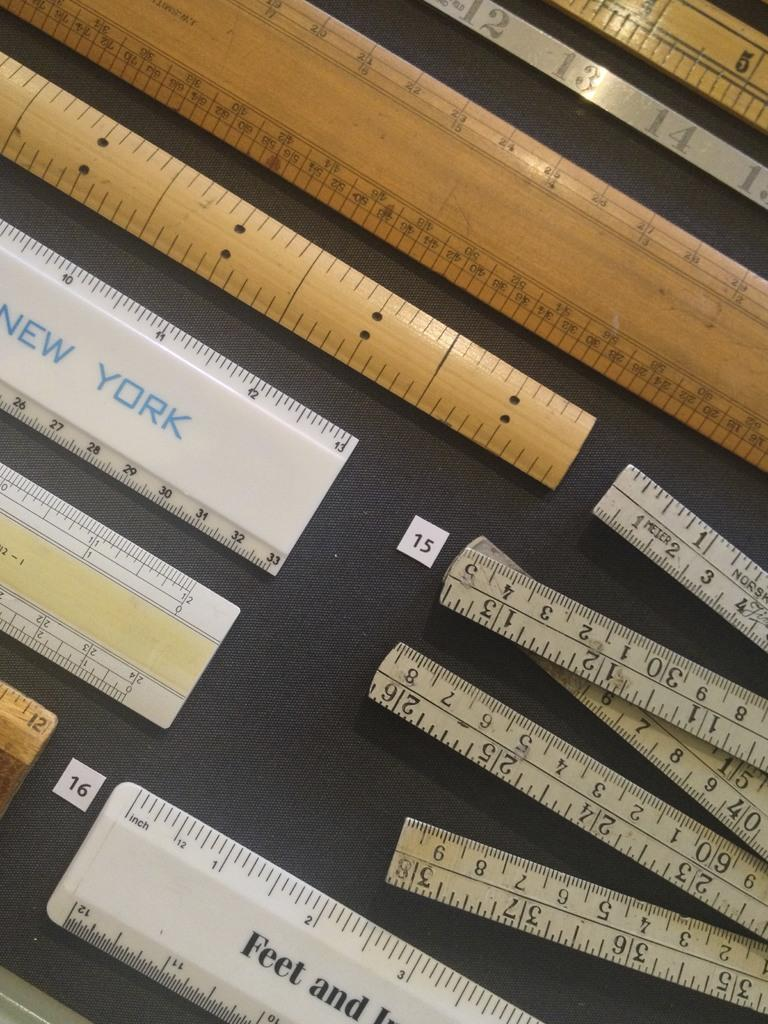<image>
Provide a brief description of the given image. Messages on a collection of rulers include the words "Feet and" and "New York". 